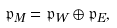<formula> <loc_0><loc_0><loc_500><loc_500>\mathfrak { p } _ { M } = \mathfrak { p } _ { W } \oplus \mathfrak { p } _ { E } ,</formula> 